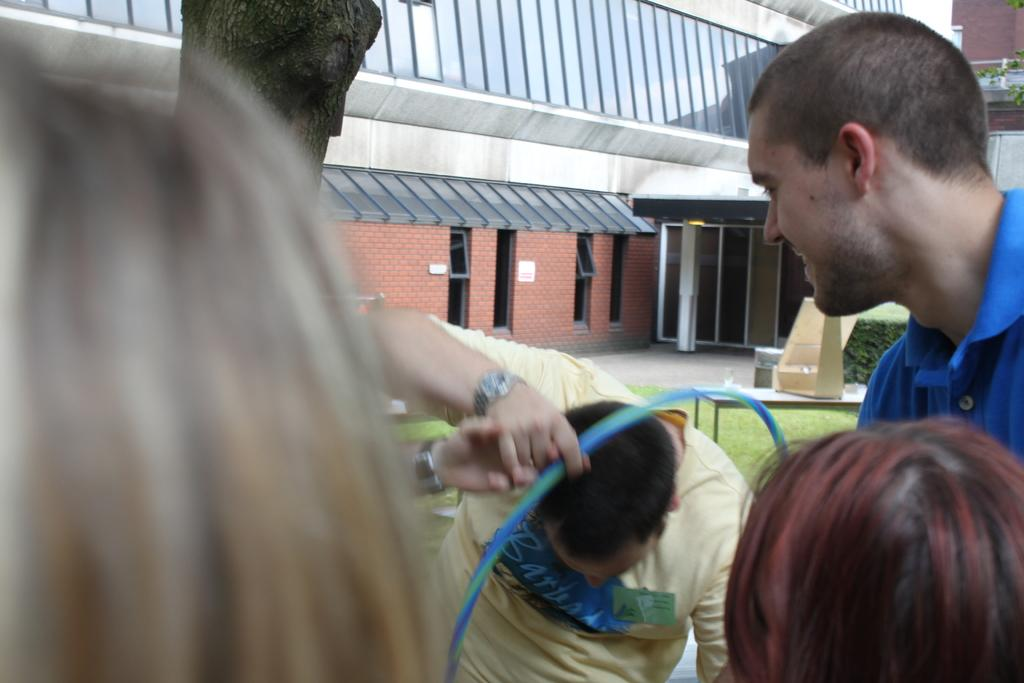How many people are visible in the image? There are people standing in the image, but the exact number is not specified. What is the person holding in the image? One of the people is holding an object, but the specific object is not described. What can be seen in the background of the image? There is a building and trees in the background of the image. What type of bulb is being used by the manager in the image? There is no manager or bulb present in the image. Can you tell me how many tigers are visible in the image? There are no tigers visible in the image. 